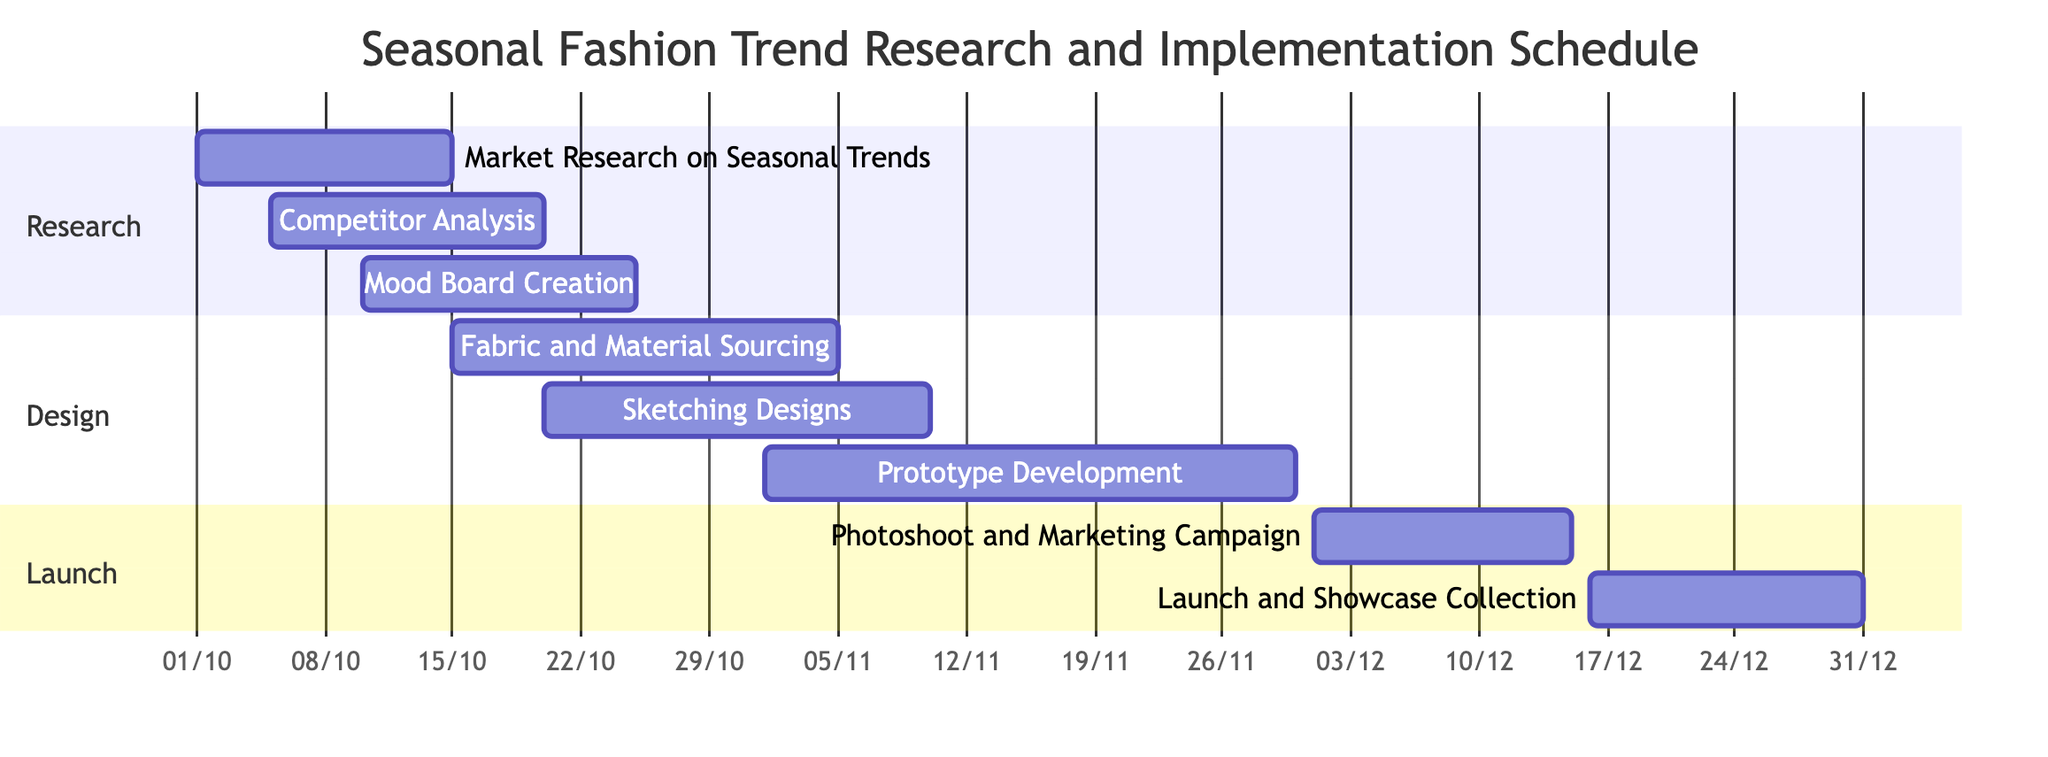What is the duration of the Market Research task? The market research task starts on October 1, 2023, and ends on October 15, 2023. The duration can be calculated as the end date minus the start date, which is 15 days.
Answer: 15 days How many tasks are in the Design section? Examining the Gantt chart, there are three tasks listed under the Design section: Fabric and Material Sourcing, Sketching Designs, and Prototype Development. Therefore, the count of tasks is 3.
Answer: 3 What task starts on November 1, 2023? Looking at the Gantt chart, the task that begins on November 1, 2023, is Prototype Development. The start date corresponds exactly to this task.
Answer: Prototype Development Which task overlaps with the Mood Board Creation? The Gantt chart shows that the Mood Board Creation task runs from October 10, 2023, to October 25, 2023. During this period, the Competitor Analysis task is also taking place from October 5, 2023, to October 20, 2023, which overlaps partially.
Answer: Competitor Analysis What is the end date of the Launch and Showcase Collection task? The Gantt chart indicates that the Launch and Showcase Collection task runs from December 16, 2023, to December 31, 2023. Therefore, the end date of this task is December 31, 2023.
Answer: December 31, 2023 Which task has the longest duration? By evaluating the tasks, the Prototype Development spans from November 1, 2023, to November 30, 2023, totaling 30 days. This is longer than any other task in the chart.
Answer: Prototype Development How many tasks begin in October 2023? Reviewing the chart, the tasks that start in October 2023 are Market Research on Seasonal Trends, Competitor Analysis, Mood Board Creation, Fabric and Material Sourcing, and Sketching Designs. There are five such tasks in total.
Answer: 5 What task follows the Photoshoot and Marketing Campaign? According to the Gantt chart, after the Photoshoot and Marketing Campaign, which ends on December 15, 2023, the next task is the Launch and Showcase Collection, starting on December 16, 2023.
Answer: Launch and Showcase Collection 